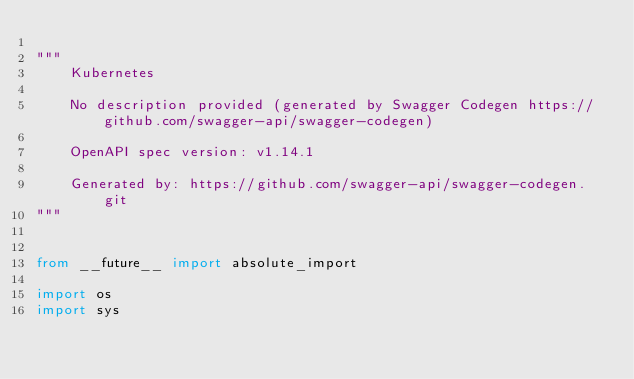Convert code to text. <code><loc_0><loc_0><loc_500><loc_500><_Python_>
"""
    Kubernetes

    No description provided (generated by Swagger Codegen https://github.com/swagger-api/swagger-codegen)

    OpenAPI spec version: v1.14.1
    
    Generated by: https://github.com/swagger-api/swagger-codegen.git
"""


from __future__ import absolute_import

import os
import sys</code> 